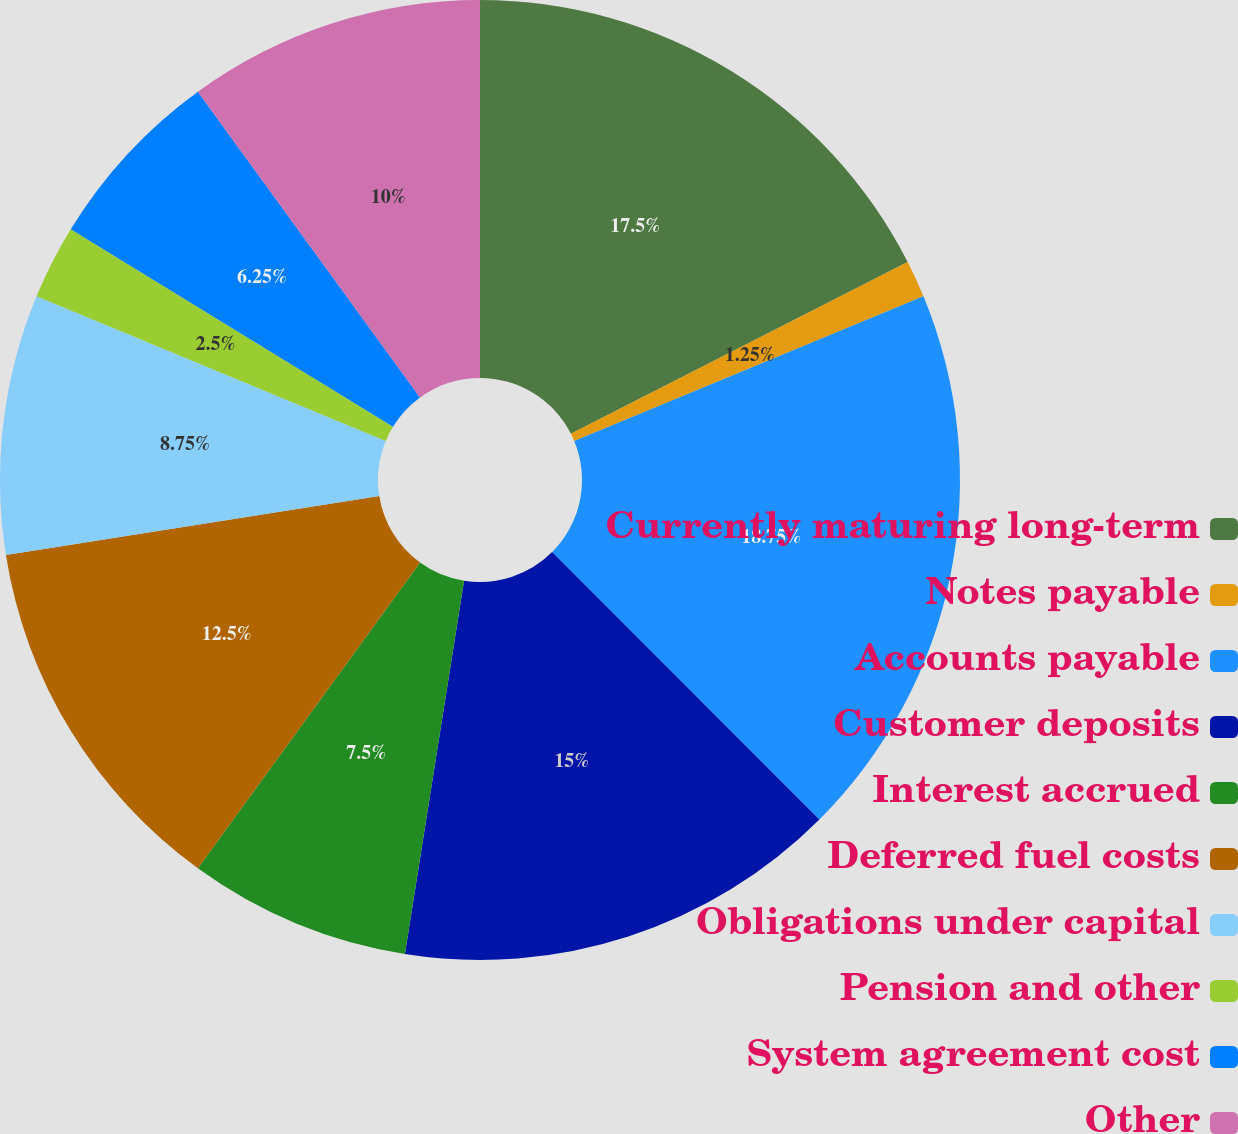<chart> <loc_0><loc_0><loc_500><loc_500><pie_chart><fcel>Currently maturing long-term<fcel>Notes payable<fcel>Accounts payable<fcel>Customer deposits<fcel>Interest accrued<fcel>Deferred fuel costs<fcel>Obligations under capital<fcel>Pension and other<fcel>System agreement cost<fcel>Other<nl><fcel>17.5%<fcel>1.25%<fcel>18.75%<fcel>15.0%<fcel>7.5%<fcel>12.5%<fcel>8.75%<fcel>2.5%<fcel>6.25%<fcel>10.0%<nl></chart> 